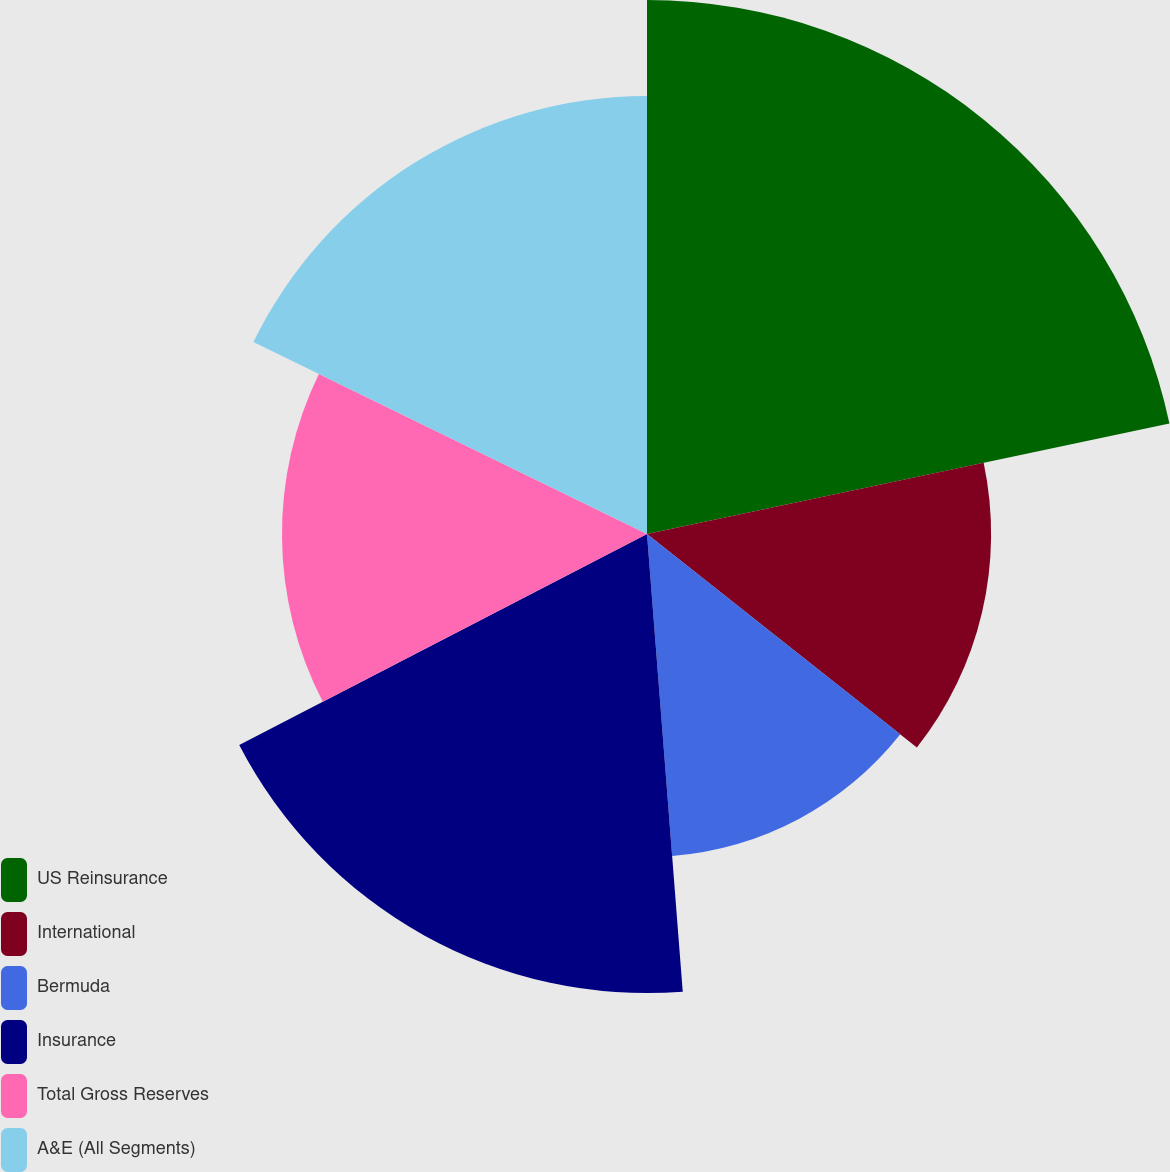<chart> <loc_0><loc_0><loc_500><loc_500><pie_chart><fcel>US Reinsurance<fcel>International<fcel>Bermuda<fcel>Insurance<fcel>Total Gross Reserves<fcel>A&E (All Segments)<nl><fcel>21.68%<fcel>13.97%<fcel>13.11%<fcel>18.64%<fcel>14.82%<fcel>17.78%<nl></chart> 